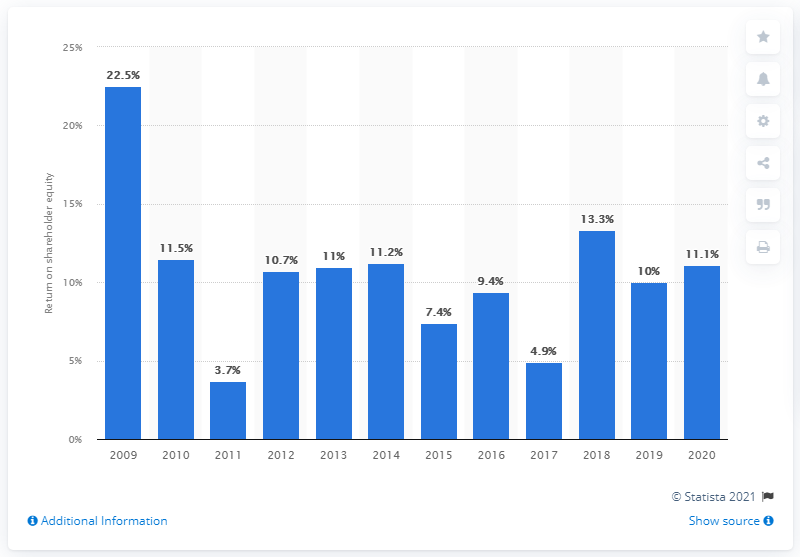Outline some significant characteristics in this image. In 2020, the average return on common shareholder equity for Goldman Sachs was 11.1%. 